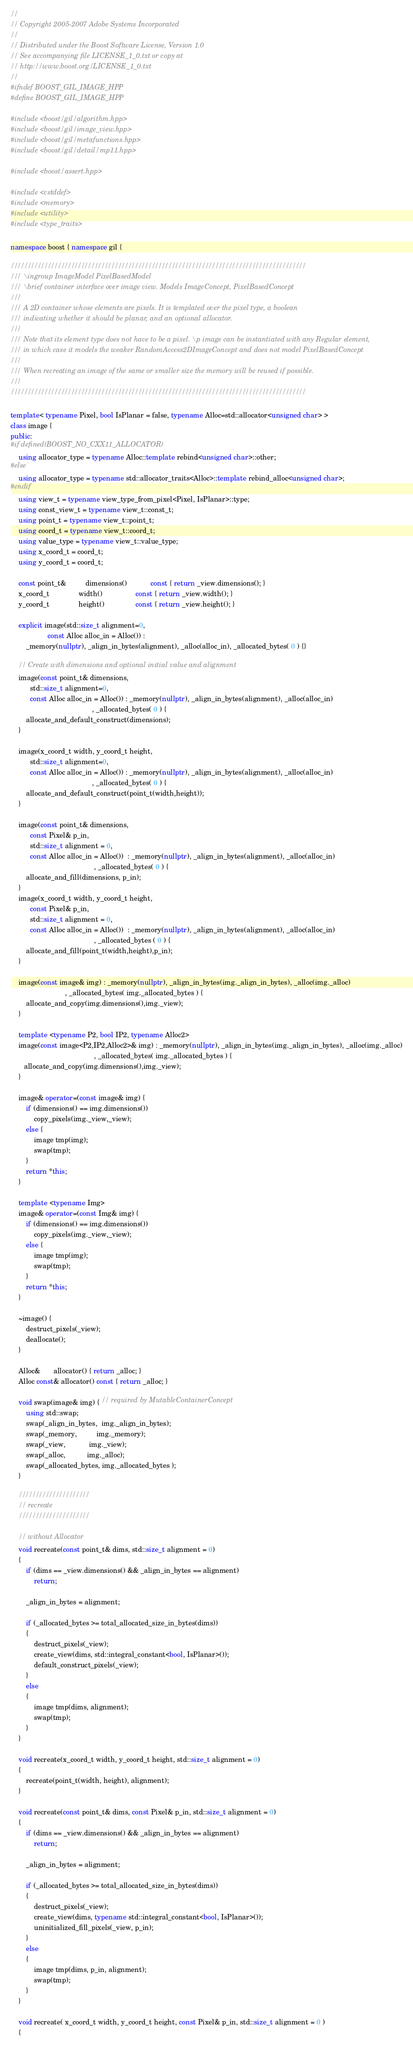<code> <loc_0><loc_0><loc_500><loc_500><_C++_>//
// Copyright 2005-2007 Adobe Systems Incorporated
//
// Distributed under the Boost Software License, Version 1.0
// See accompanying file LICENSE_1_0.txt or copy at
// http://www.boost.org/LICENSE_1_0.txt
//
#ifndef BOOST_GIL_IMAGE_HPP
#define BOOST_GIL_IMAGE_HPP

#include <boost/gil/algorithm.hpp>
#include <boost/gil/image_view.hpp>
#include <boost/gil/metafunctions.hpp>
#include <boost/gil/detail/mp11.hpp>

#include <boost/assert.hpp>

#include <cstddef>
#include <memory>
#include <utility>
#include <type_traits>

namespace boost { namespace gil {

////////////////////////////////////////////////////////////////////////////////////////
/// \ingroup ImageModel PixelBasedModel
/// \brief container interface over image view. Models ImageConcept, PixelBasedConcept
///
/// A 2D container whose elements are pixels. It is templated over the pixel type, a boolean
/// indicating whether it should be planar, and an optional allocator.
///
/// Note that its element type does not have to be a pixel. \p image can be instantiated with any Regular element,
/// in which case it models the weaker RandomAccess2DImageConcept and does not model PixelBasedConcept
///
/// When recreating an image of the same or smaller size the memory will be reused if possible.
///
////////////////////////////////////////////////////////////////////////////////////////

template< typename Pixel, bool IsPlanar = false, typename Alloc=std::allocator<unsigned char> >
class image {
public:
#if defined(BOOST_NO_CXX11_ALLOCATOR)
    using allocator_type = typename Alloc::template rebind<unsigned char>::other;
#else
    using allocator_type = typename std::allocator_traits<Alloc>::template rebind_alloc<unsigned char>;
#endif
    using view_t = typename view_type_from_pixel<Pixel, IsPlanar>::type;
    using const_view_t = typename view_t::const_t;
    using point_t = typename view_t::point_t;
    using coord_t = typename view_t::coord_t;
    using value_type = typename view_t::value_type;
    using x_coord_t = coord_t;
    using y_coord_t = coord_t;

    const point_t&          dimensions()            const { return _view.dimensions(); }
    x_coord_t               width()                 const { return _view.width(); }
    y_coord_t               height()                const { return _view.height(); }

    explicit image(std::size_t alignment=0,
                   const Alloc alloc_in = Alloc()) :
        _memory(nullptr), _align_in_bytes(alignment), _alloc(alloc_in), _allocated_bytes( 0 ) {}

    // Create with dimensions and optional initial value and alignment
    image(const point_t& dimensions,
          std::size_t alignment=0,
          const Alloc alloc_in = Alloc()) : _memory(nullptr), _align_in_bytes(alignment), _alloc(alloc_in)
                                          , _allocated_bytes( 0 ) {
        allocate_and_default_construct(dimensions);
    }

    image(x_coord_t width, y_coord_t height,
          std::size_t alignment=0,
          const Alloc alloc_in = Alloc()) : _memory(nullptr), _align_in_bytes(alignment), _alloc(alloc_in)
                                          , _allocated_bytes( 0 ) {
        allocate_and_default_construct(point_t(width,height));
    }

    image(const point_t& dimensions,
          const Pixel& p_in,
          std::size_t alignment = 0,
          const Alloc alloc_in = Alloc())  : _memory(nullptr), _align_in_bytes(alignment), _alloc(alloc_in)
                                           , _allocated_bytes( 0 ) {
        allocate_and_fill(dimensions, p_in);
    }
    image(x_coord_t width, y_coord_t height,
          const Pixel& p_in,
          std::size_t alignment = 0,
          const Alloc alloc_in = Alloc())  : _memory(nullptr), _align_in_bytes(alignment), _alloc(alloc_in)
                                           , _allocated_bytes ( 0 ) {
        allocate_and_fill(point_t(width,height),p_in);
    }

    image(const image& img) : _memory(nullptr), _align_in_bytes(img._align_in_bytes), _alloc(img._alloc)
                            , _allocated_bytes( img._allocated_bytes ) {
        allocate_and_copy(img.dimensions(),img._view);
    }

    template <typename P2, bool IP2, typename Alloc2>
    image(const image<P2,IP2,Alloc2>& img) : _memory(nullptr), _align_in_bytes(img._align_in_bytes), _alloc(img._alloc)
                                           , _allocated_bytes( img._allocated_bytes ) {
       allocate_and_copy(img.dimensions(),img._view);
    }

    image& operator=(const image& img) {
        if (dimensions() == img.dimensions())
            copy_pixels(img._view,_view);
        else {
            image tmp(img);
            swap(tmp);
        }
        return *this;
    }

    template <typename Img>
    image& operator=(const Img& img) {
        if (dimensions() == img.dimensions())
            copy_pixels(img._view,_view);
        else {
            image tmp(img);
            swap(tmp);
        }
        return *this;
    }

    ~image() {
        destruct_pixels(_view);
        deallocate();
    }

    Alloc&       allocator() { return _alloc; }
    Alloc const& allocator() const { return _alloc; }

    void swap(image& img) { // required by MutableContainerConcept
        using std::swap;
        swap(_align_in_bytes,  img._align_in_bytes);
        swap(_memory,          img._memory);
        swap(_view,            img._view);
        swap(_alloc,           img._alloc);
        swap(_allocated_bytes, img._allocated_bytes );
    }

    /////////////////////
    // recreate
    /////////////////////

    // without Allocator
    void recreate(const point_t& dims, std::size_t alignment = 0)
    {
        if (dims == _view.dimensions() && _align_in_bytes == alignment)
            return;

        _align_in_bytes = alignment;

        if (_allocated_bytes >= total_allocated_size_in_bytes(dims))
        {
            destruct_pixels(_view);
            create_view(dims, std::integral_constant<bool, IsPlanar>());
            default_construct_pixels(_view);
        }
        else
        {
            image tmp(dims, alignment);
            swap(tmp);
        }
    }

    void recreate(x_coord_t width, y_coord_t height, std::size_t alignment = 0)
    {
        recreate(point_t(width, height), alignment);
    }

    void recreate(const point_t& dims, const Pixel& p_in, std::size_t alignment = 0)
    {
        if (dims == _view.dimensions() && _align_in_bytes == alignment)
            return;

        _align_in_bytes = alignment;

        if (_allocated_bytes >= total_allocated_size_in_bytes(dims))
        {
            destruct_pixels(_view);
            create_view(dims, typename std::integral_constant<bool, IsPlanar>());
            uninitialized_fill_pixels(_view, p_in);
        }
        else
        {
            image tmp(dims, p_in, alignment);
            swap(tmp);
        }
    }

    void recreate( x_coord_t width, y_coord_t height, const Pixel& p_in, std::size_t alignment = 0 )
    {</code> 